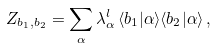Convert formula to latex. <formula><loc_0><loc_0><loc_500><loc_500>Z _ { b _ { 1 } , b _ { 2 } } = \sum _ { \alpha } \lambda _ { \alpha } ^ { l } \, \langle b _ { 1 } | \alpha \rangle \langle b _ { 2 } | \alpha \rangle \, ,</formula> 